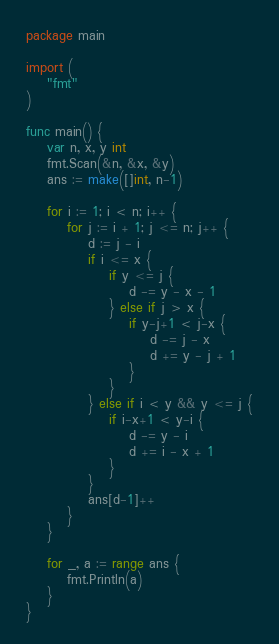Convert code to text. <code><loc_0><loc_0><loc_500><loc_500><_Go_>package main

import (
	"fmt"
)

func main() {
	var n, x, y int
	fmt.Scan(&n, &x, &y)
	ans := make([]int, n-1)

	for i := 1; i < n; i++ {
		for j := i + 1; j <= n; j++ {
			d := j - i
			if i <= x {
				if y <= j {
					d -= y - x - 1
				} else if j > x {
					if y-j+1 < j-x {
						d -= j - x
						d += y - j + 1
					}
				}
			} else if i < y && y <= j {
				if i-x+1 < y-i {
					d -= y - i
					d += i - x + 1
				}
			}
			ans[d-1]++
		}
	}

	for _, a := range ans {
		fmt.Println(a)
	}
}
</code> 